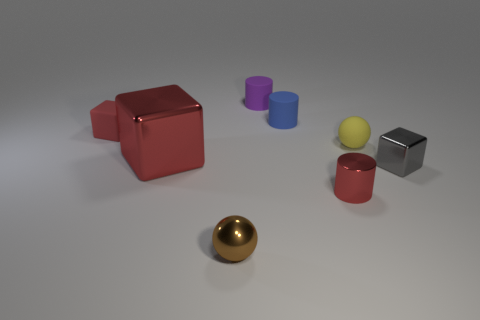Are the blue object and the ball that is on the left side of the blue rubber thing made of the same material?
Offer a very short reply. No. There is a tiny rubber object on the left side of the brown thing; is its color the same as the large shiny thing?
Provide a short and direct response. Yes. The red metal block has what size?
Ensure brevity in your answer.  Large. Is the color of the small shiny cylinder the same as the tiny block that is behind the tiny yellow sphere?
Provide a short and direct response. Yes. There is a blue object behind the yellow matte thing; is it the same size as the shiny block that is left of the brown shiny ball?
Your response must be concise. No. Is the gray block made of the same material as the tiny yellow object?
Offer a very short reply. No. What is the size of the red shiny object that is the same shape as the tiny gray thing?
Provide a short and direct response. Large. There is a brown sphere; does it have the same size as the matte thing that is to the right of the blue object?
Offer a very short reply. Yes. What number of metallic objects are large yellow balls or red cubes?
Give a very brief answer. 1. Are there more big red metal cubes than gray spheres?
Keep it short and to the point. Yes. 